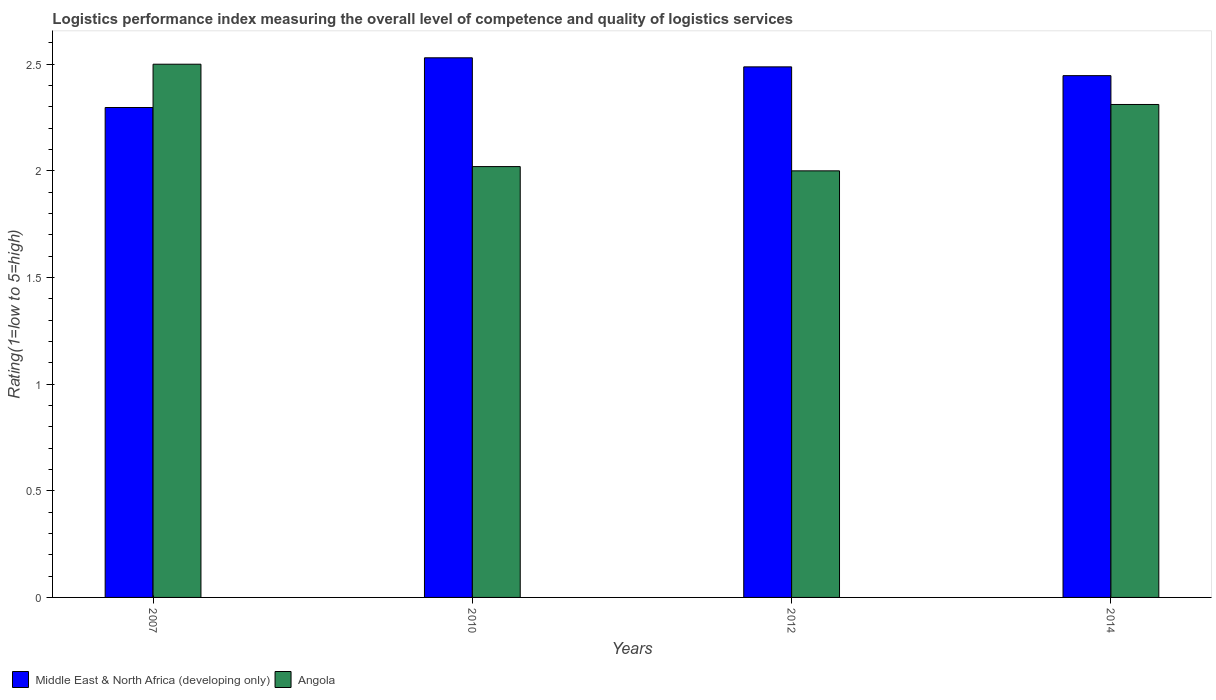Are the number of bars per tick equal to the number of legend labels?
Make the answer very short. Yes. Are the number of bars on each tick of the X-axis equal?
Your response must be concise. Yes. How many bars are there on the 4th tick from the left?
Provide a short and direct response. 2. How many bars are there on the 4th tick from the right?
Ensure brevity in your answer.  2. In how many cases, is the number of bars for a given year not equal to the number of legend labels?
Keep it short and to the point. 0. What is the Logistic performance index in Middle East & North Africa (developing only) in 2007?
Make the answer very short. 2.3. Across all years, what is the minimum Logistic performance index in Middle East & North Africa (developing only)?
Your answer should be compact. 2.3. What is the total Logistic performance index in Middle East & North Africa (developing only) in the graph?
Provide a succinct answer. 9.76. What is the difference between the Logistic performance index in Middle East & North Africa (developing only) in 2007 and that in 2010?
Give a very brief answer. -0.23. What is the difference between the Logistic performance index in Middle East & North Africa (developing only) in 2014 and the Logistic performance index in Angola in 2012?
Your answer should be very brief. 0.45. What is the average Logistic performance index in Angola per year?
Provide a succinct answer. 2.21. In the year 2007, what is the difference between the Logistic performance index in Angola and Logistic performance index in Middle East & North Africa (developing only)?
Offer a very short reply. 0.2. In how many years, is the Logistic performance index in Middle East & North Africa (developing only) greater than 2.3?
Your answer should be compact. 3. What is the ratio of the Logistic performance index in Angola in 2007 to that in 2014?
Provide a succinct answer. 1.08. What is the difference between the highest and the second highest Logistic performance index in Angola?
Offer a terse response. 0.19. What does the 1st bar from the left in 2007 represents?
Your answer should be very brief. Middle East & North Africa (developing only). What does the 1st bar from the right in 2010 represents?
Provide a short and direct response. Angola. How many years are there in the graph?
Provide a succinct answer. 4. Where does the legend appear in the graph?
Offer a very short reply. Bottom left. How many legend labels are there?
Ensure brevity in your answer.  2. How are the legend labels stacked?
Provide a short and direct response. Horizontal. What is the title of the graph?
Offer a very short reply. Logistics performance index measuring the overall level of competence and quality of logistics services. Does "Mozambique" appear as one of the legend labels in the graph?
Your response must be concise. No. What is the label or title of the Y-axis?
Give a very brief answer. Rating(1=low to 5=high). What is the Rating(1=low to 5=high) in Middle East & North Africa (developing only) in 2007?
Your answer should be very brief. 2.3. What is the Rating(1=low to 5=high) of Angola in 2007?
Provide a succinct answer. 2.5. What is the Rating(1=low to 5=high) of Middle East & North Africa (developing only) in 2010?
Offer a very short reply. 2.53. What is the Rating(1=low to 5=high) in Angola in 2010?
Your response must be concise. 2.02. What is the Rating(1=low to 5=high) of Middle East & North Africa (developing only) in 2012?
Provide a short and direct response. 2.49. What is the Rating(1=low to 5=high) in Middle East & North Africa (developing only) in 2014?
Your answer should be compact. 2.45. What is the Rating(1=low to 5=high) in Angola in 2014?
Ensure brevity in your answer.  2.31. Across all years, what is the maximum Rating(1=low to 5=high) in Middle East & North Africa (developing only)?
Your response must be concise. 2.53. Across all years, what is the minimum Rating(1=low to 5=high) in Middle East & North Africa (developing only)?
Keep it short and to the point. 2.3. Across all years, what is the minimum Rating(1=low to 5=high) in Angola?
Offer a very short reply. 2. What is the total Rating(1=low to 5=high) of Middle East & North Africa (developing only) in the graph?
Your answer should be compact. 9.76. What is the total Rating(1=low to 5=high) of Angola in the graph?
Your answer should be very brief. 8.83. What is the difference between the Rating(1=low to 5=high) of Middle East & North Africa (developing only) in 2007 and that in 2010?
Offer a very short reply. -0.23. What is the difference between the Rating(1=low to 5=high) in Angola in 2007 and that in 2010?
Provide a succinct answer. 0.48. What is the difference between the Rating(1=low to 5=high) in Middle East & North Africa (developing only) in 2007 and that in 2012?
Give a very brief answer. -0.19. What is the difference between the Rating(1=low to 5=high) in Angola in 2007 and that in 2012?
Provide a succinct answer. 0.5. What is the difference between the Rating(1=low to 5=high) in Middle East & North Africa (developing only) in 2007 and that in 2014?
Your response must be concise. -0.15. What is the difference between the Rating(1=low to 5=high) in Angola in 2007 and that in 2014?
Give a very brief answer. 0.19. What is the difference between the Rating(1=low to 5=high) in Middle East & North Africa (developing only) in 2010 and that in 2012?
Give a very brief answer. 0.04. What is the difference between the Rating(1=low to 5=high) in Angola in 2010 and that in 2012?
Provide a short and direct response. 0.02. What is the difference between the Rating(1=low to 5=high) of Middle East & North Africa (developing only) in 2010 and that in 2014?
Give a very brief answer. 0.08. What is the difference between the Rating(1=low to 5=high) in Angola in 2010 and that in 2014?
Your answer should be very brief. -0.29. What is the difference between the Rating(1=low to 5=high) in Middle East & North Africa (developing only) in 2012 and that in 2014?
Give a very brief answer. 0.04. What is the difference between the Rating(1=low to 5=high) in Angola in 2012 and that in 2014?
Your answer should be compact. -0.31. What is the difference between the Rating(1=low to 5=high) in Middle East & North Africa (developing only) in 2007 and the Rating(1=low to 5=high) in Angola in 2010?
Ensure brevity in your answer.  0.28. What is the difference between the Rating(1=low to 5=high) of Middle East & North Africa (developing only) in 2007 and the Rating(1=low to 5=high) of Angola in 2012?
Your response must be concise. 0.3. What is the difference between the Rating(1=low to 5=high) in Middle East & North Africa (developing only) in 2007 and the Rating(1=low to 5=high) in Angola in 2014?
Give a very brief answer. -0.01. What is the difference between the Rating(1=low to 5=high) in Middle East & North Africa (developing only) in 2010 and the Rating(1=low to 5=high) in Angola in 2012?
Offer a very short reply. 0.53. What is the difference between the Rating(1=low to 5=high) of Middle East & North Africa (developing only) in 2010 and the Rating(1=low to 5=high) of Angola in 2014?
Provide a short and direct response. 0.22. What is the difference between the Rating(1=low to 5=high) in Middle East & North Africa (developing only) in 2012 and the Rating(1=low to 5=high) in Angola in 2014?
Offer a very short reply. 0.18. What is the average Rating(1=low to 5=high) of Middle East & North Africa (developing only) per year?
Your answer should be very brief. 2.44. What is the average Rating(1=low to 5=high) of Angola per year?
Make the answer very short. 2.21. In the year 2007, what is the difference between the Rating(1=low to 5=high) of Middle East & North Africa (developing only) and Rating(1=low to 5=high) of Angola?
Give a very brief answer. -0.2. In the year 2010, what is the difference between the Rating(1=low to 5=high) in Middle East & North Africa (developing only) and Rating(1=low to 5=high) in Angola?
Offer a very short reply. 0.51. In the year 2012, what is the difference between the Rating(1=low to 5=high) in Middle East & North Africa (developing only) and Rating(1=low to 5=high) in Angola?
Offer a terse response. 0.49. In the year 2014, what is the difference between the Rating(1=low to 5=high) in Middle East & North Africa (developing only) and Rating(1=low to 5=high) in Angola?
Provide a succinct answer. 0.14. What is the ratio of the Rating(1=low to 5=high) of Middle East & North Africa (developing only) in 2007 to that in 2010?
Your response must be concise. 0.91. What is the ratio of the Rating(1=low to 5=high) of Angola in 2007 to that in 2010?
Ensure brevity in your answer.  1.24. What is the ratio of the Rating(1=low to 5=high) of Middle East & North Africa (developing only) in 2007 to that in 2012?
Ensure brevity in your answer.  0.92. What is the ratio of the Rating(1=low to 5=high) in Angola in 2007 to that in 2012?
Your answer should be compact. 1.25. What is the ratio of the Rating(1=low to 5=high) in Middle East & North Africa (developing only) in 2007 to that in 2014?
Keep it short and to the point. 0.94. What is the ratio of the Rating(1=low to 5=high) in Angola in 2007 to that in 2014?
Provide a short and direct response. 1.08. What is the ratio of the Rating(1=low to 5=high) in Middle East & North Africa (developing only) in 2010 to that in 2012?
Offer a very short reply. 1.02. What is the ratio of the Rating(1=low to 5=high) of Middle East & North Africa (developing only) in 2010 to that in 2014?
Your answer should be very brief. 1.03. What is the ratio of the Rating(1=low to 5=high) in Angola in 2010 to that in 2014?
Your answer should be very brief. 0.87. What is the ratio of the Rating(1=low to 5=high) of Middle East & North Africa (developing only) in 2012 to that in 2014?
Make the answer very short. 1.02. What is the ratio of the Rating(1=low to 5=high) of Angola in 2012 to that in 2014?
Provide a succinct answer. 0.87. What is the difference between the highest and the second highest Rating(1=low to 5=high) of Middle East & North Africa (developing only)?
Offer a terse response. 0.04. What is the difference between the highest and the second highest Rating(1=low to 5=high) of Angola?
Offer a terse response. 0.19. What is the difference between the highest and the lowest Rating(1=low to 5=high) of Middle East & North Africa (developing only)?
Your answer should be very brief. 0.23. 